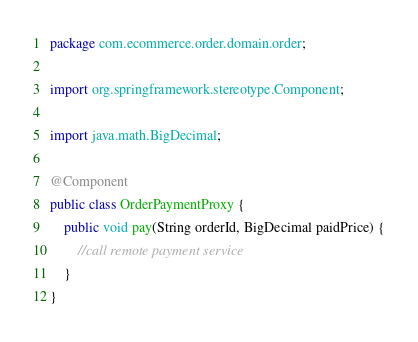Convert code to text. <code><loc_0><loc_0><loc_500><loc_500><_Java_>package com.ecommerce.order.domain.order;

import org.springframework.stereotype.Component;

import java.math.BigDecimal;

@Component
public class OrderPaymentProxy {
    public void pay(String orderId, BigDecimal paidPrice) {
        //call remote payment service
    }
}
</code> 